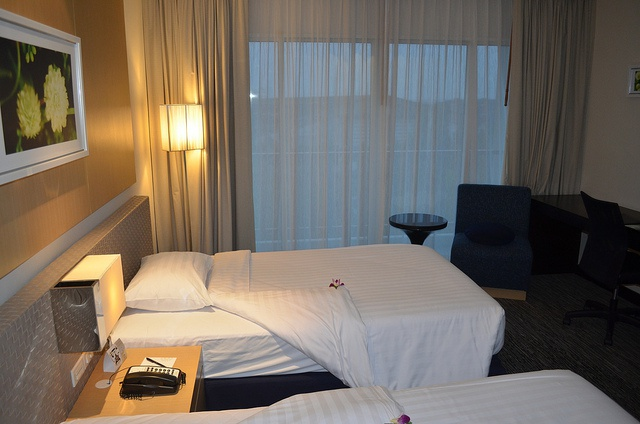Describe the objects in this image and their specific colors. I can see bed in brown, darkgray, tan, and black tones, bed in brown, darkgray, gray, and tan tones, chair in brown, black, blue, navy, and gray tones, chair in brown, black, and gray tones, and dining table in brown, black, blue, and darkblue tones in this image. 